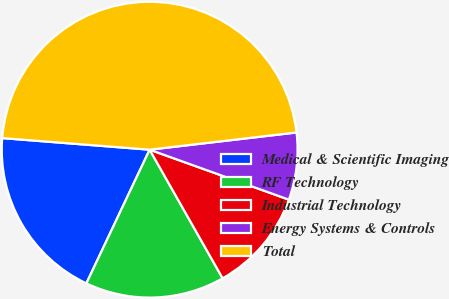Convert chart to OTSL. <chart><loc_0><loc_0><loc_500><loc_500><pie_chart><fcel>Medical & Scientific Imaging<fcel>RF Technology<fcel>Industrial Technology<fcel>Energy Systems & Controls<fcel>Total<nl><fcel>19.21%<fcel>15.25%<fcel>11.3%<fcel>7.34%<fcel>46.89%<nl></chart> 